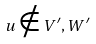<formula> <loc_0><loc_0><loc_500><loc_500>u \notin V ^ { \prime } , W ^ { \prime }</formula> 